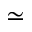<formula> <loc_0><loc_0><loc_500><loc_500>\simeq</formula> 